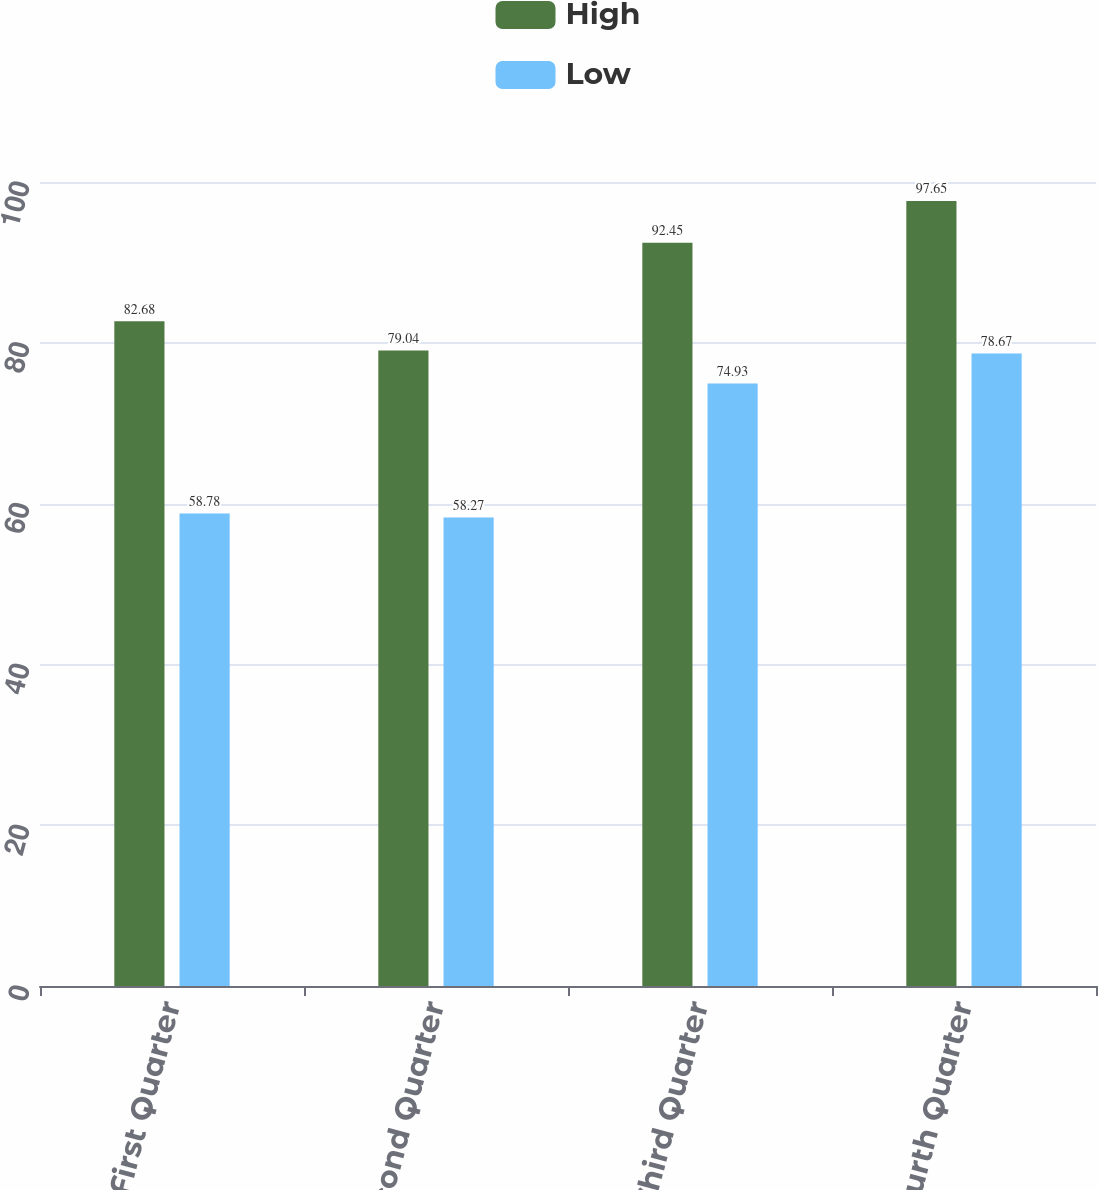<chart> <loc_0><loc_0><loc_500><loc_500><stacked_bar_chart><ecel><fcel>First Quarter<fcel>Second Quarter<fcel>Third Quarter<fcel>Fourth Quarter<nl><fcel>High<fcel>82.68<fcel>79.04<fcel>92.45<fcel>97.65<nl><fcel>Low<fcel>58.78<fcel>58.27<fcel>74.93<fcel>78.67<nl></chart> 